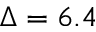Convert formula to latex. <formula><loc_0><loc_0><loc_500><loc_500>\Delta = 6 . 4</formula> 